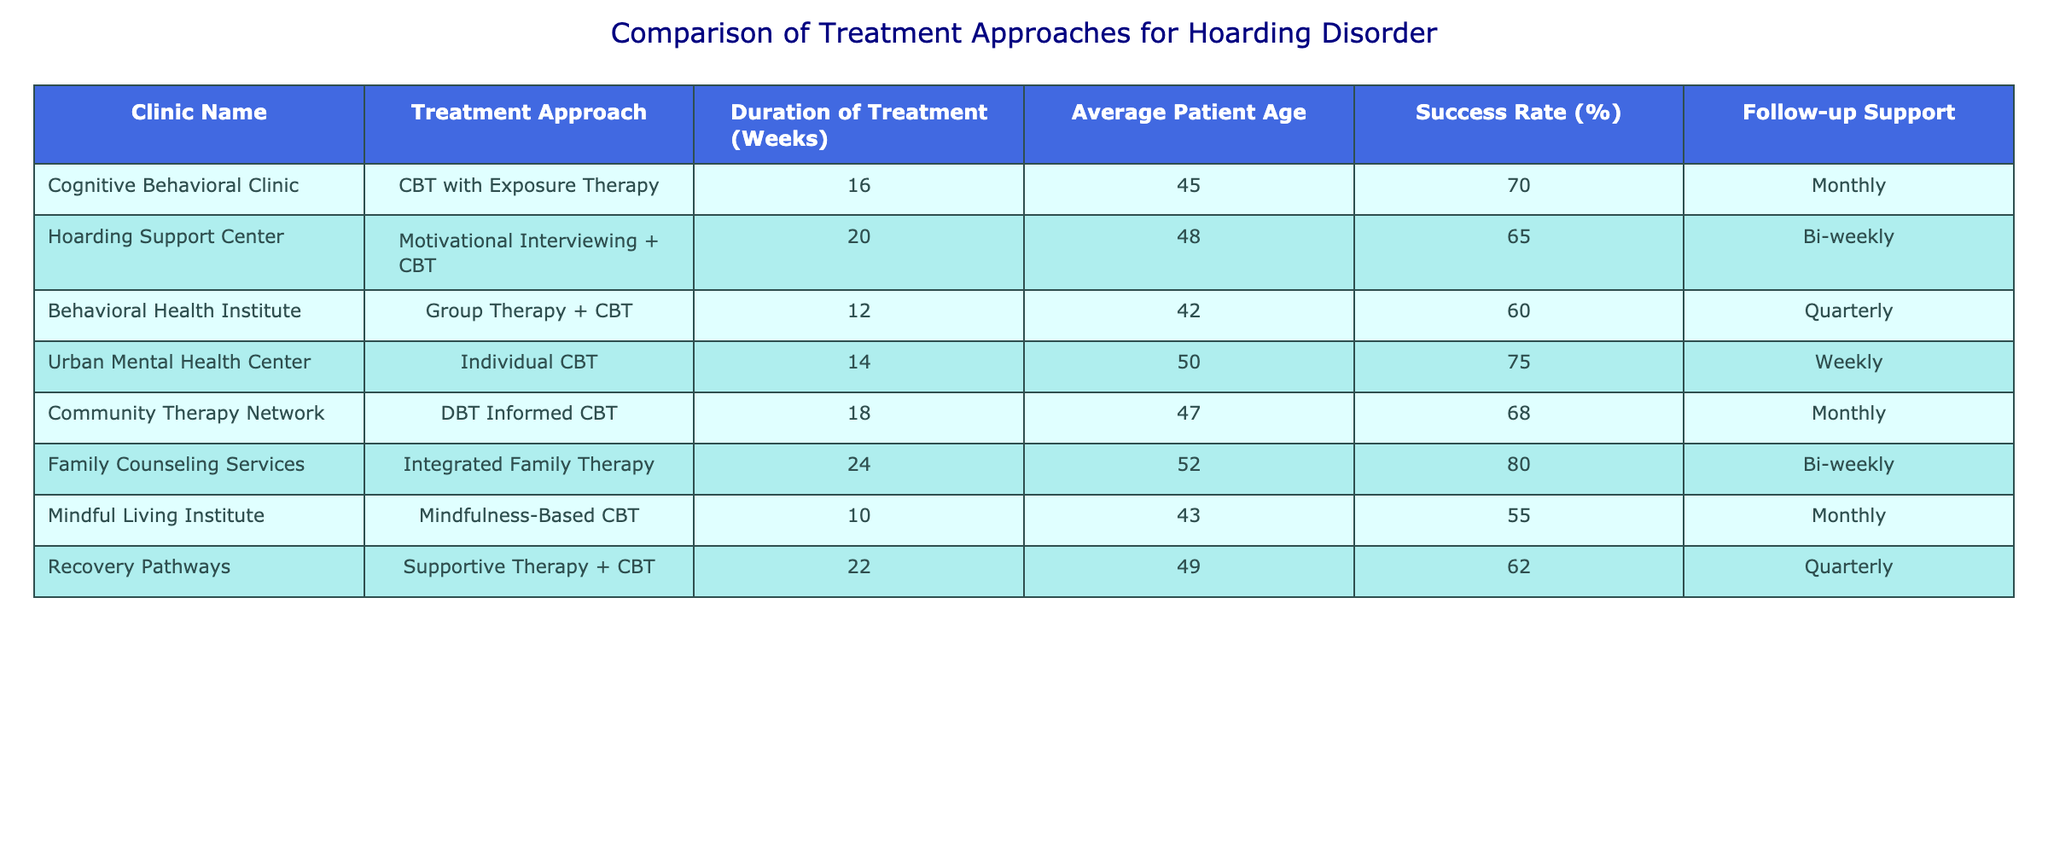What is the success rate of the Family Counseling Services? The success rate of the Family Counseling Services is clearly listed under the "Success Rate (%)" column, which shows a value of 80%.
Answer: 80% Which treatment approach has the longest duration? By scanning through the "Duration of Treatment (Weeks)" column, we can see that the Integrated Family Therapy has the maximum value of 24 weeks, indicating it is the longest.
Answer: 24 weeks Is the success rate of Group Therapy + CBT higher than that of Mindfulness-Based CBT? The success rate of Group Therapy + CBT is 60%, while the success rate for Mindfulness-Based CBT is 55%. Since 60% is greater than 55%, the statement is true.
Answer: Yes What is the average success rate for clinics that provide Individual therapy approaches? The clinics that provide Individual therapy are the Urban Mental Health Center (75%) and the Family Counseling Services (80%). To find the average, we sum these values: 75 + 80 = 155, and then divide by the number of clinics (2). The average success rate is 155 / 2 = 77.5%.
Answer: 77.5% How many clinics have a success rate above 65%? The clinics with a success rate above 65% are the Cognitive Behavioral Clinic (70%), Urban Mental Health Center (75%), and Family Counseling Services (80%). Counting them gives us a total of three clinics.
Answer: 3 What is the difference in average patient age between the Cognitive Behavioral Clinic and the Hoarding Support Center? The average patient age for the Cognitive Behavioral Clinic is 45 and for the Hoarding Support Center it is 48. To find the difference, we subtract the younger age from the older age: 48 - 45 = 3 years.
Answer: 3 years Are there any clinics that have follow-up support on a weekly basis? By looking under the "Follow-up Support" column, we see that Urban Mental Health Center is noted for weekly follow-up support, hence the answer is yes.
Answer: Yes Which treatment approach has the highest success rate? By examining the "Success Rate (%)" column, we see that Integrated Family Therapy has the highest success rate at 80%, making it the most successful approach listed.
Answer: Integrated Family Therapy What treatment approach is associated with the youngest average patient age? We can compare the age values in the "Average Patient Age" column. The Mindful Living Institute has an average patient age of 43, which is lower than all the other clinics, indicating this approach is associated with the youngest patients.
Answer: Mindfulness-Based CBT 